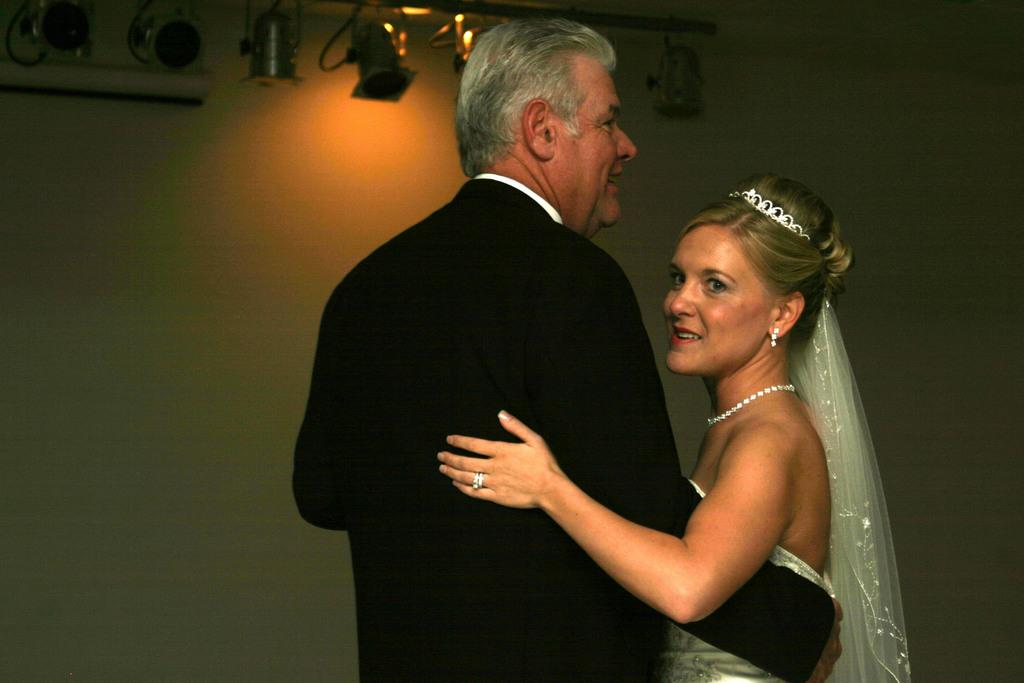What is the man in the image wearing? The man in the image is wearing a black suit. What is the woman in the image wearing? The woman in the image is wearing a bridal dress. What can be seen at the top of the image? There are lights visible at the top of the image. What color is the wall in the background? The wall in the background is painted white. What type of grip can be seen on the church gate in the image? There is no church or gate present in the image. 